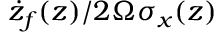<formula> <loc_0><loc_0><loc_500><loc_500>\dot { z } _ { f } ( z ) / 2 \Omega \sigma _ { x } ( z )</formula> 